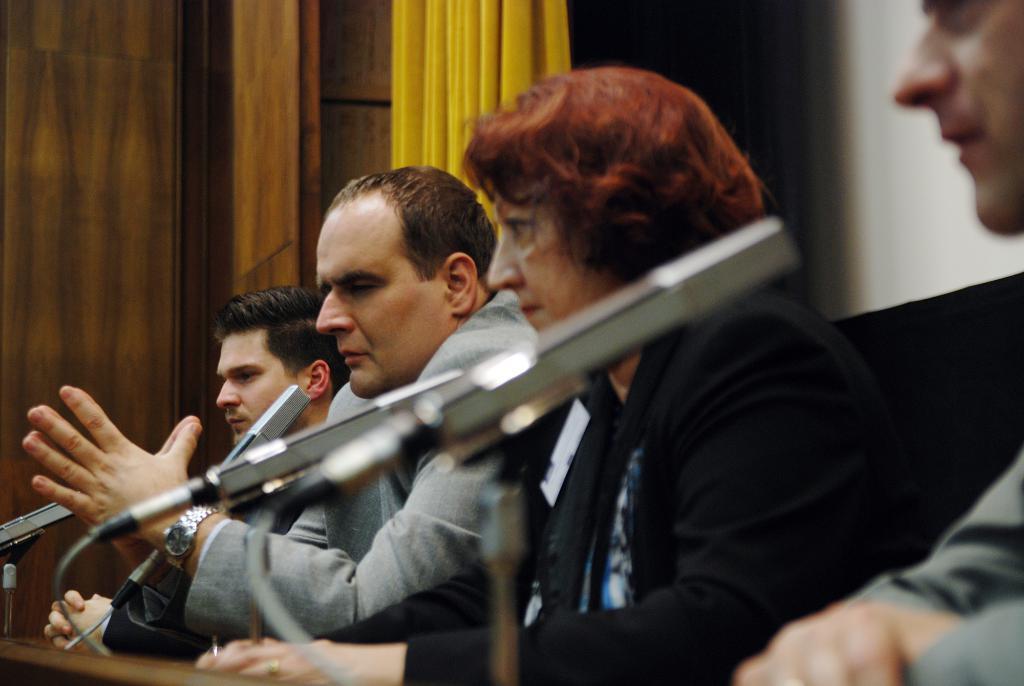Can you describe this image briefly? In this image there are people sitting on chairs, in front of them there is a table, on that table there are mike's, in the background there is a wooden wall and a curtain. 